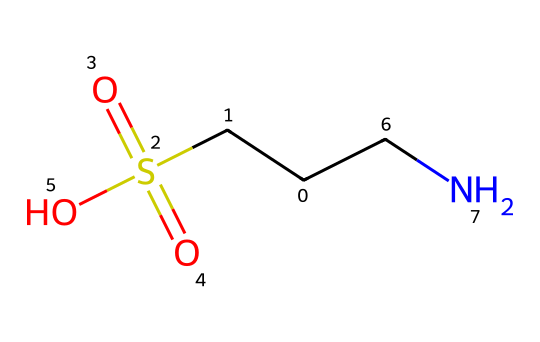What is the molecular formula of taurine? To find the molecular formula, we identify the atoms within the structure from the SMILES. The SMILES represents 2 carbon atoms (C), 7 hydrogen atoms (H), 1 nitrogen atom (N), and 3 oxygen atoms (O) along with a sulfonic group. Combining these gives us the molecular formula C2H7NO3S.
Answer: C2H7NO3S How many sulfur atoms are in taurine? By examining the structure in the SMILES representation, we see a single instance of "S(=O)(=O)", indicating the presence of one sulfur atom.
Answer: 1 What type of functional group is present in taurine? The presence of the sulfonic acid functional group is indicated by the "S(=O)(=O)O" portion of the SMILES, which contains a sulfur atom bonded to two oxygen atoms with double bonds and one oxygen atom with a single bond. This characterizes it as a sulfonic acid.
Answer: sulfonic acid How many total bonds are present in taurine? The structure can be analyzed by counting the bonds formed between the atoms. There are single bonds between carbons and nitrogens, and the sulfonic acid group introduces two double bonds and one single bond. This gives a total of 7 bonds.
Answer: 7 Is taurine an amino acid? Without the presence of a carboxylic acid functional group (-COOH), which is characteristic of amino acids, we see only an amine and a sulfonic acid. Therefore, taurine is classified as an amino sulfonic acid rather than a standard amino acid.
Answer: no How many oxygen atoms are present in taurine? From the "S(=O)(=O)O" part of the SMILES, we identify three oxygen atoms. One from the sulfonic group and the other two are part of the double bonds to sulfur.
Answer: 3 